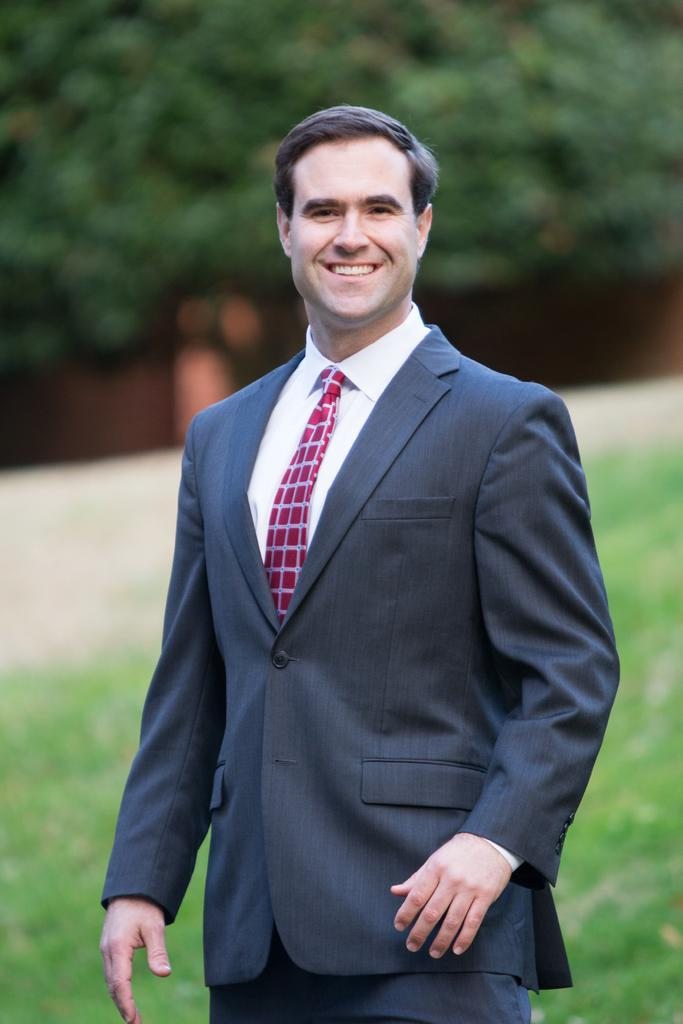Who or what is present in the image? There is a person in the image. What is the person wearing? The person is wearing a coat and tie. Where is the person standing? The person is standing on the ground. What can be seen in the background of the image? There is grass and a group of trees visible in the background. Can you see any owls or pigs playing baseball in the image? No, there are no owls, pigs, or baseball game present in the image. 